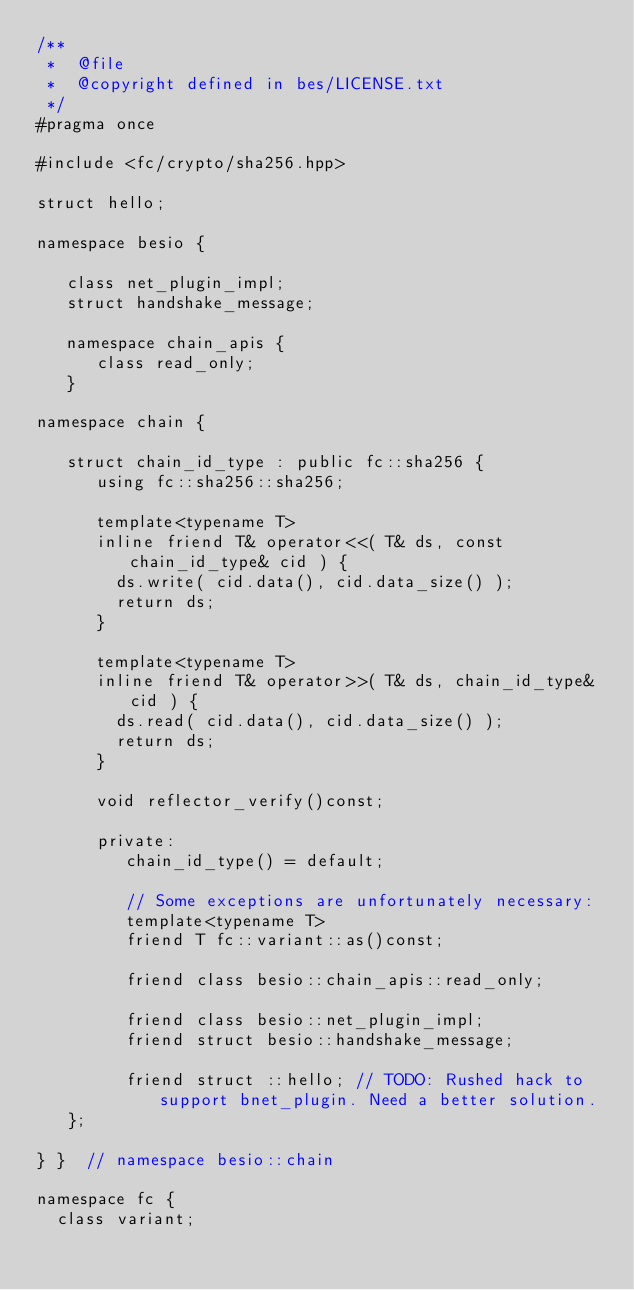<code> <loc_0><loc_0><loc_500><loc_500><_C++_>/**
 *  @file
 *  @copyright defined in bes/LICENSE.txt
 */
#pragma once

#include <fc/crypto/sha256.hpp>

struct hello;

namespace besio {

   class net_plugin_impl;
   struct handshake_message;

   namespace chain_apis {
      class read_only;
   }

namespace chain {

   struct chain_id_type : public fc::sha256 {
      using fc::sha256::sha256;

      template<typename T>
      inline friend T& operator<<( T& ds, const chain_id_type& cid ) {
        ds.write( cid.data(), cid.data_size() );
        return ds;
      }

      template<typename T>
      inline friend T& operator>>( T& ds, chain_id_type& cid ) {
        ds.read( cid.data(), cid.data_size() );
        return ds;
      }

      void reflector_verify()const;

      private:
         chain_id_type() = default;

         // Some exceptions are unfortunately necessary:
         template<typename T>
         friend T fc::variant::as()const;

         friend class besio::chain_apis::read_only;

         friend class besio::net_plugin_impl;
         friend struct besio::handshake_message;

         friend struct ::hello; // TODO: Rushed hack to support bnet_plugin. Need a better solution.
   };

} }  // namespace besio::chain

namespace fc {
  class variant;</code> 